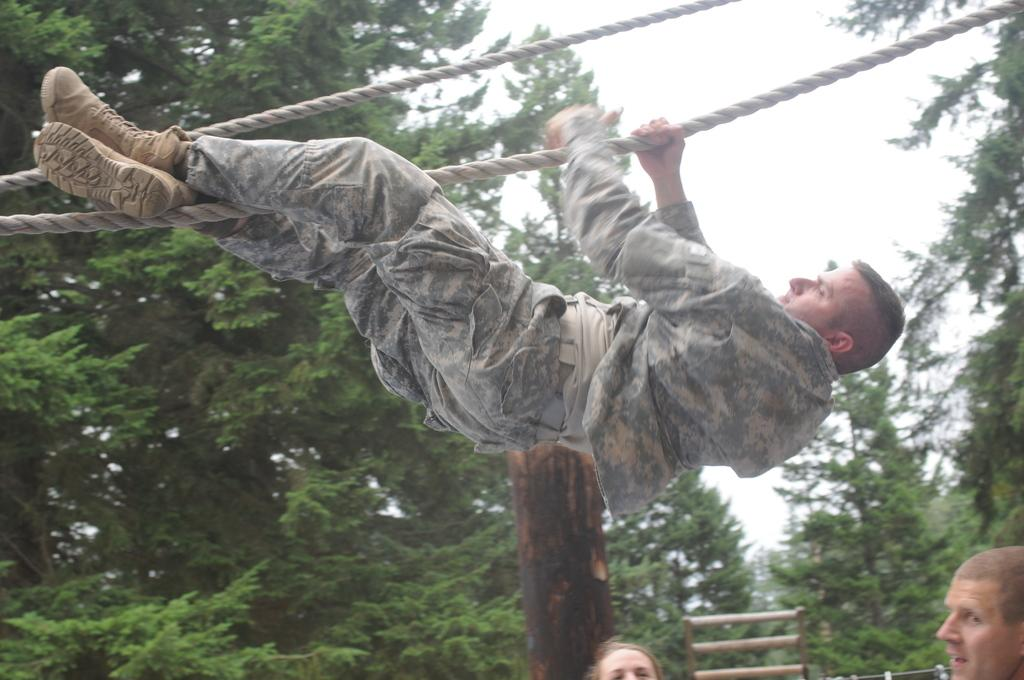How many persons are in the image? There are persons in the image. What is one person doing in the image? One person is hanging on a rope. What object is present in the image that is made of wood? There is a wooden pole in the image. What type of objects can be seen in the image that are long and thin? There are sticks in the image. What can be seen in the sky in the image? The sky is visible in the image. What type of vegetation is present in the image? There are trees in the image. What type of wine is being served at the volleyball game in the image? There is no wine or volleyball game present in the image. 